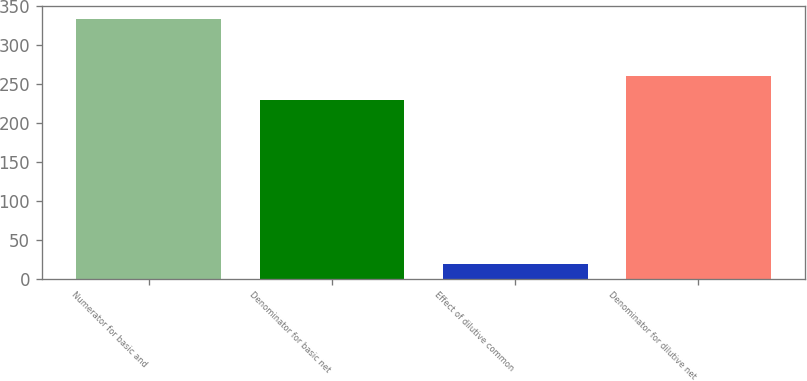Convert chart. <chart><loc_0><loc_0><loc_500><loc_500><bar_chart><fcel>Numerator for basic and<fcel>Denominator for basic net<fcel>Effect of dilutive common<fcel>Denominator for dilutive net<nl><fcel>333.6<fcel>229<fcel>18.5<fcel>260.51<nl></chart> 